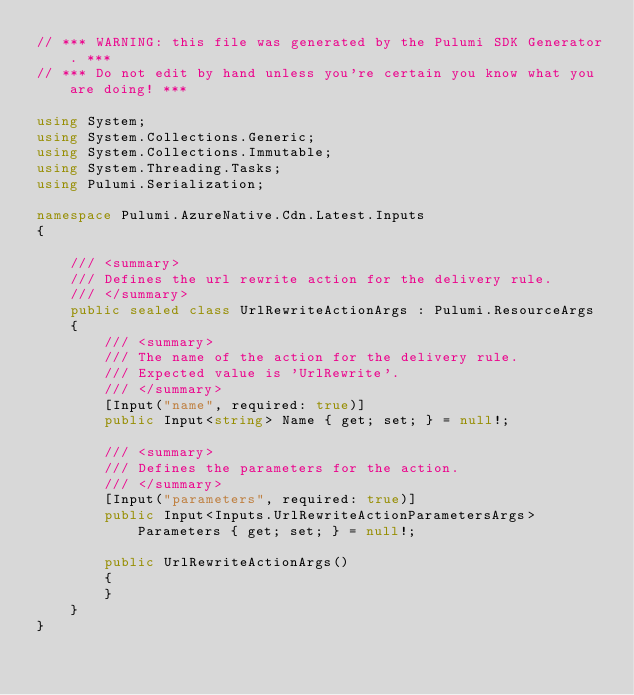Convert code to text. <code><loc_0><loc_0><loc_500><loc_500><_C#_>// *** WARNING: this file was generated by the Pulumi SDK Generator. ***
// *** Do not edit by hand unless you're certain you know what you are doing! ***

using System;
using System.Collections.Generic;
using System.Collections.Immutable;
using System.Threading.Tasks;
using Pulumi.Serialization;

namespace Pulumi.AzureNative.Cdn.Latest.Inputs
{

    /// <summary>
    /// Defines the url rewrite action for the delivery rule.
    /// </summary>
    public sealed class UrlRewriteActionArgs : Pulumi.ResourceArgs
    {
        /// <summary>
        /// The name of the action for the delivery rule.
        /// Expected value is 'UrlRewrite'.
        /// </summary>
        [Input("name", required: true)]
        public Input<string> Name { get; set; } = null!;

        /// <summary>
        /// Defines the parameters for the action.
        /// </summary>
        [Input("parameters", required: true)]
        public Input<Inputs.UrlRewriteActionParametersArgs> Parameters { get; set; } = null!;

        public UrlRewriteActionArgs()
        {
        }
    }
}
</code> 